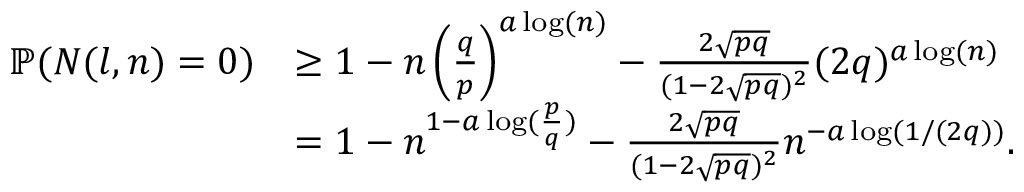<formula> <loc_0><loc_0><loc_500><loc_500>\begin{array} { r l } { \mathbb { P } ( N ( l , n ) = 0 ) } & { \geq 1 - n \left ( \frac { q } { p } \right ) ^ { a \log ( n ) } - \frac { 2 \sqrt { p q } } { ( 1 - 2 \sqrt { p q } ) ^ { 2 } } ( 2 q ) ^ { a \log ( n ) } } \\ & { = 1 - n ^ { 1 - a \log ( \frac { p } { q } ) } - \frac { 2 \sqrt { p q } } { ( 1 - 2 \sqrt { p q } ) ^ { 2 } } n ^ { - a \log ( 1 / ( 2 q ) ) } . } \end{array}</formula> 